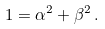Convert formula to latex. <formula><loc_0><loc_0><loc_500><loc_500>1 = \alpha ^ { 2 } + \beta ^ { 2 } \, .</formula> 